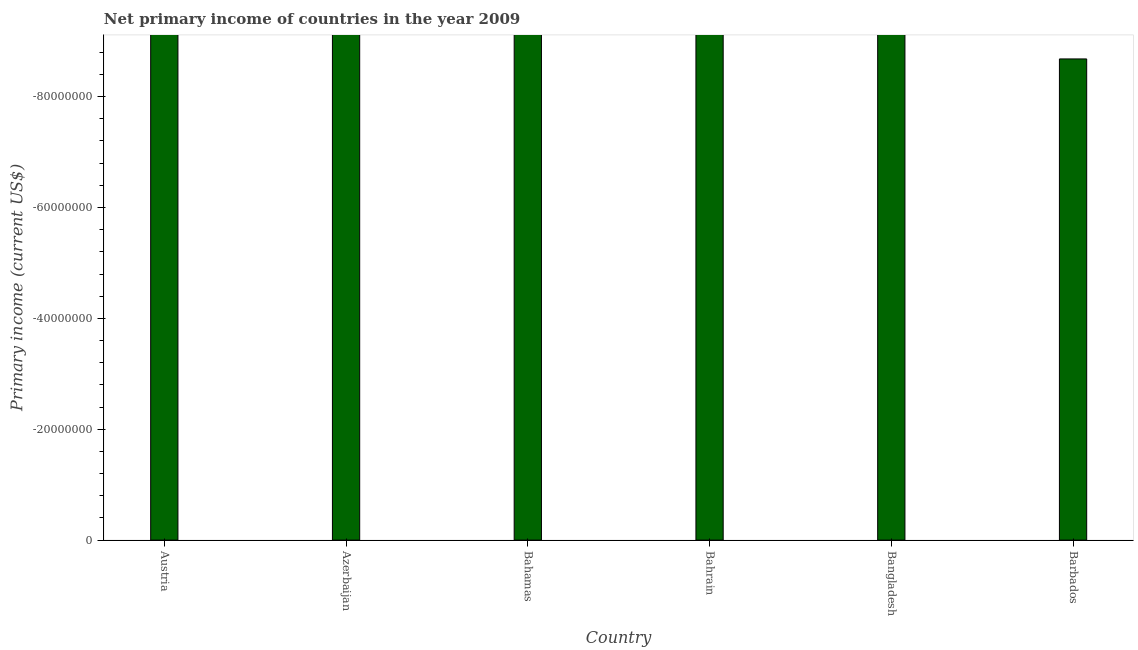What is the title of the graph?
Provide a short and direct response. Net primary income of countries in the year 2009. What is the label or title of the Y-axis?
Your response must be concise. Primary income (current US$). What is the amount of primary income in Azerbaijan?
Your response must be concise. 0. What is the average amount of primary income per country?
Make the answer very short. 0. In how many countries, is the amount of primary income greater than -68000000 US$?
Offer a very short reply. 0. How many bars are there?
Your answer should be compact. 0. What is the Primary income (current US$) in Austria?
Offer a very short reply. 0. What is the Primary income (current US$) in Azerbaijan?
Make the answer very short. 0. What is the Primary income (current US$) in Bahamas?
Your answer should be compact. 0. What is the Primary income (current US$) in Barbados?
Make the answer very short. 0. 